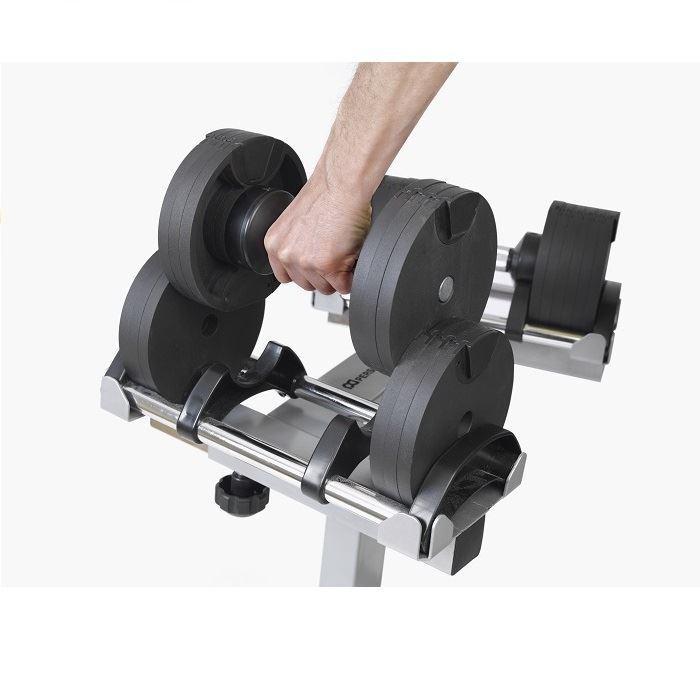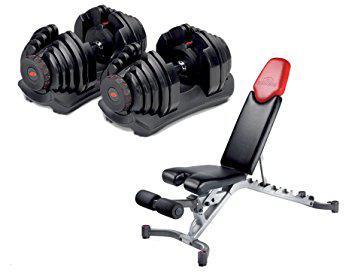The first image is the image on the left, the second image is the image on the right. Considering the images on both sides, is "A person is interacting with the weights in the image on the right." valid? Answer yes or no. No. The first image is the image on the left, the second image is the image on the right. Given the left and right images, does the statement "A person is touching the dumbbells in the right image only." hold true? Answer yes or no. No. 